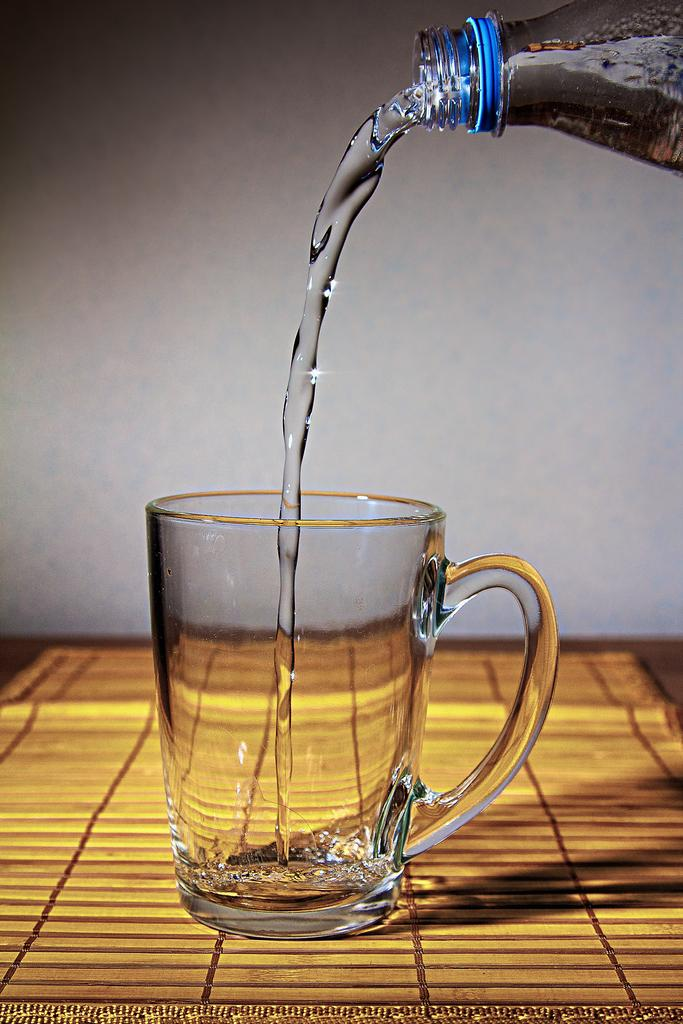What is in the glass that is visible in the image? The glass is filled with water. Where is the glass located in the image? The glass is on a table. What is behind the table in the image? There is a wall in front of the table. What type of skin can be seen on the drawer in the image? There is no drawer or skin present in the image. How is the uncle related to the glass in the image? There is no uncle mentioned or depicted in the image. 